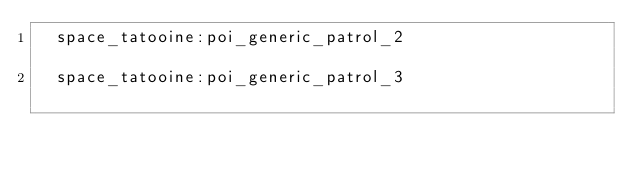Convert code to text. <code><loc_0><loc_0><loc_500><loc_500><_SQL_>	space_tatooine:poi_generic_patrol_2													
	space_tatooine:poi_generic_patrol_3													
</code> 